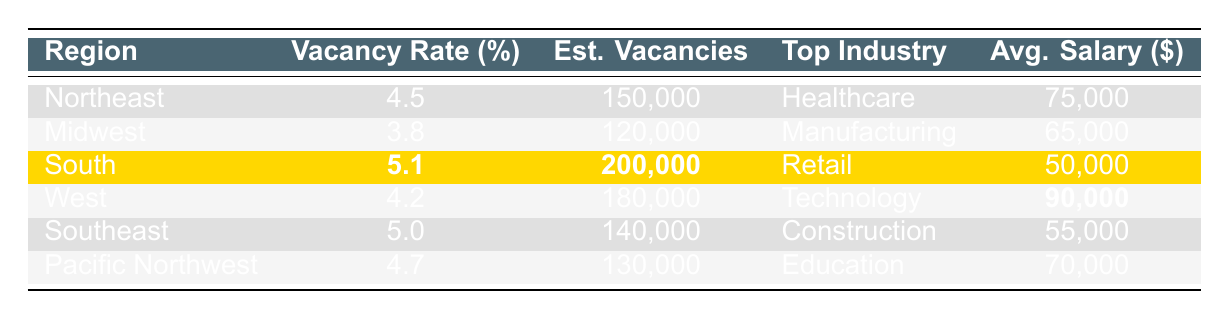What is the job vacancy rate in the South? The job vacancy rate for the South is highlighted in the table, which shows it to be 5.1%.
Answer: 5.1% Which region has the highest estimated vacancies? By comparing the estimated vacancies across the regions, the South has the highest at 200,000.
Answer: South What is the average salary for the top industry in the Midwest? The top industry in the Midwest is Manufacturing, and the average salary listed in the table for that industry is $65,000.
Answer: $65,000 Is the average salary in the Northeast higher than that in the Southeast? The average salary in the Northeast is $75,000 while in the Southeast, it is $55,000. Since $75,000 is greater than $55,000, the statement is true.
Answer: Yes What is the overall average vacancy rate for all regions listed? The vacancy rates are 4.5%, 3.8%, 5.1%, 4.2%, 5.0%, and 4.7%. Summing these gives 27.3%, and dividing by 6 regions gives an average vacancy rate of 4.55%.
Answer: 4.55% Which region has the lowest average salary? The Southeast has the lowest average salary shown in the table at $55,000 compared to all other regions.
Answer: Southeast If we combine the estimated vacancies of the Northeast and Midwest, what is the total? The estimated vacancies in the Northeast and Midwest are 150,000 and 120,000 respectively. Adding these gives a total of 270,000 estimated vacancies.
Answer: 270,000 Are there more estimated vacancies in the West than in the Pacific Northwest? The West has 180,000 estimated vacancies while the Pacific Northwest has 130,000. Comparing these shows that 180,000 is greater than 130,000.
Answer: Yes What is the difference in average salaries between the Technology and Retail industries? The average salary for Technology is $90,000 and for Retail is $50,000. Subtracting these gives a difference of $40,000.
Answer: $40,000 Which industry has the highest average salary among the listed regions? Looking at the average salaries, Technology has the highest at $90,000, compared to the others listed.
Answer: Technology 